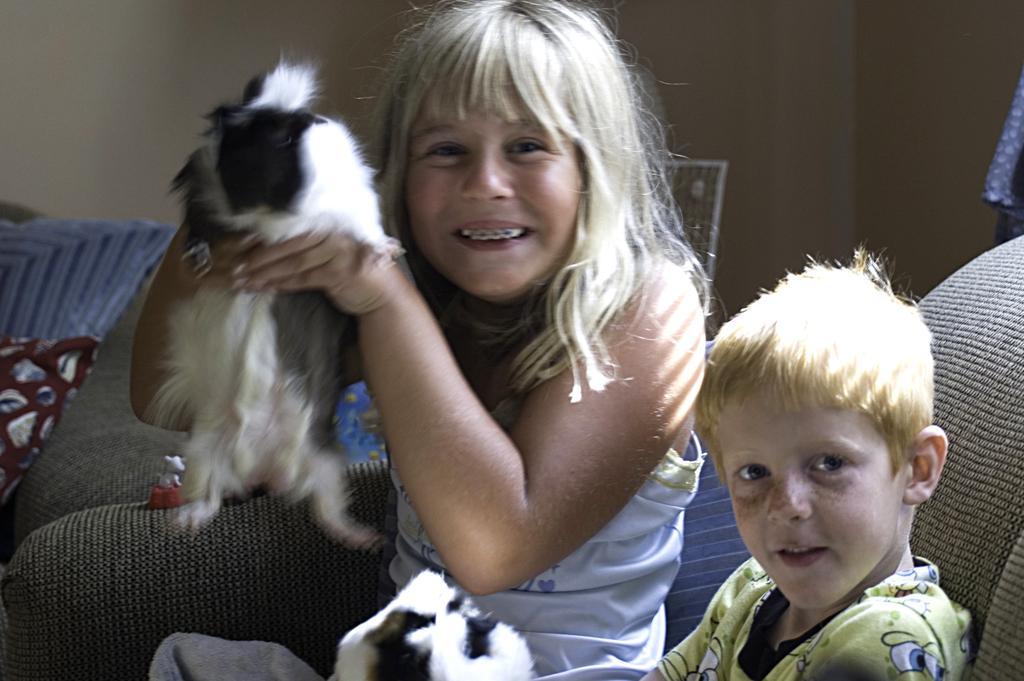Please provide a concise description of this image. In this image i can see a girl holding a dog on her hand and she is smiling and beside her there a boy sitting on the chair 